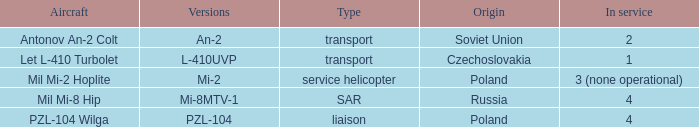Tell me the service for versions l-410uvp 1.0. 